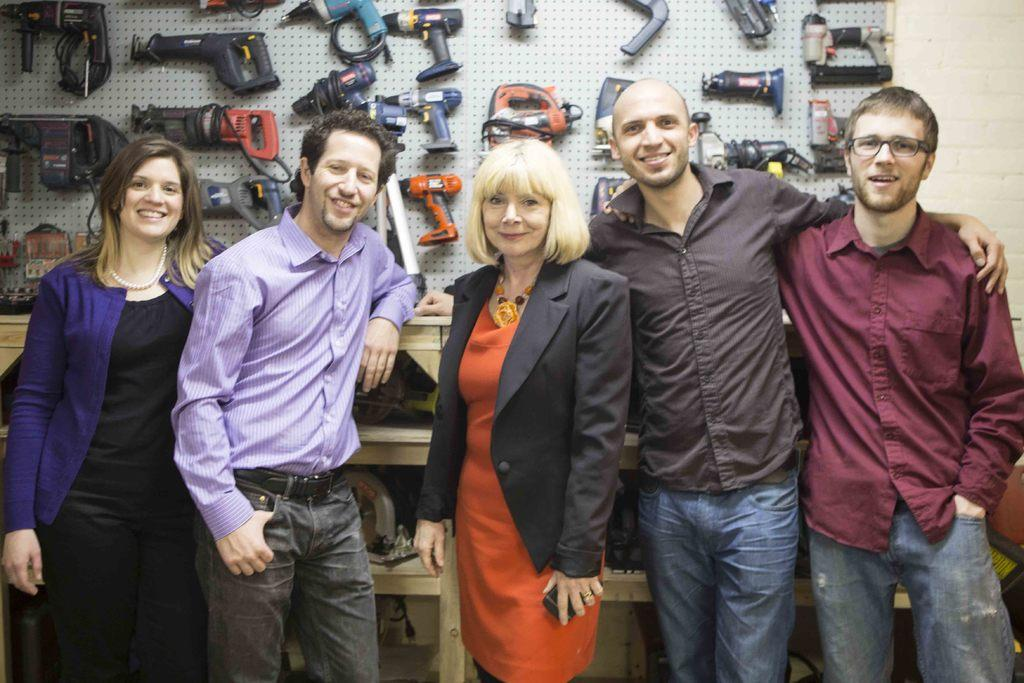How many people are present in the image? There are two women and three men in the image, making a total of five people. What are the people in the image doing? The people are standing in the image. What can be seen on the wall in the background of the image? There are tools on the wall in the background of the image. What type of page is being turned in the image? There is no page or book present in the image, so no page is being turned. What treatment is being administered to the person in the image? There is no person receiving any treatment in the image; it features a group of people standing. 